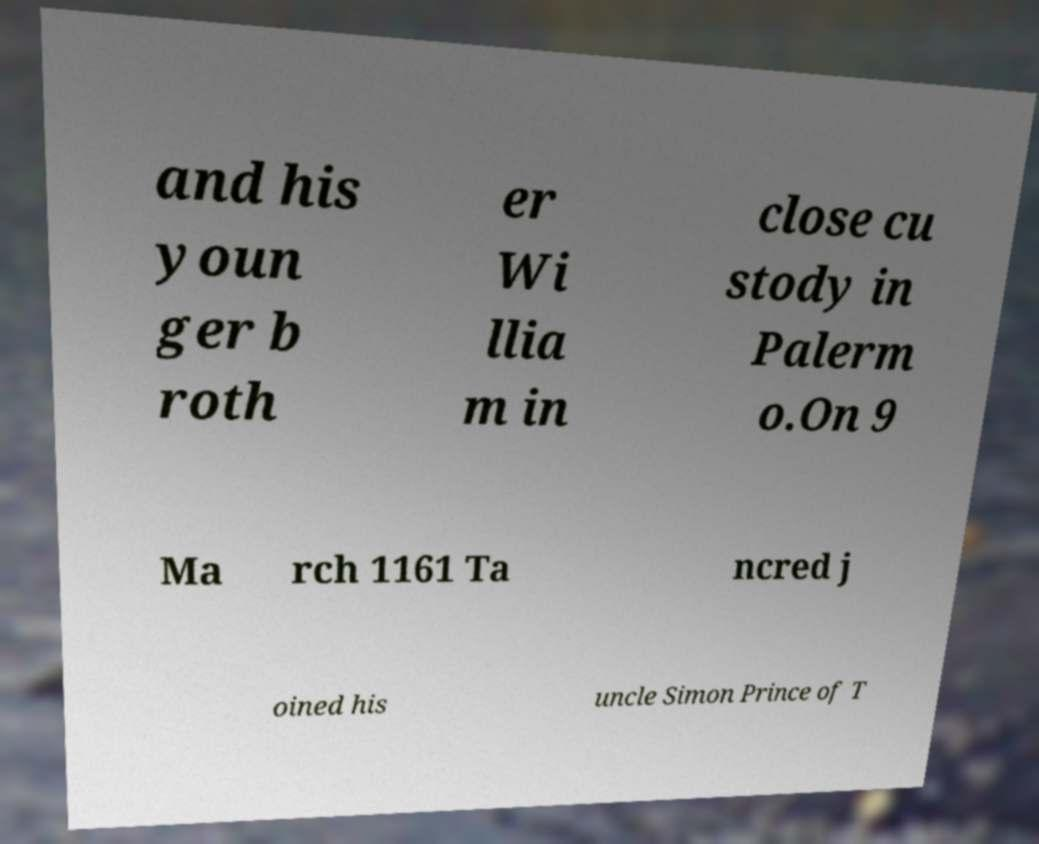What messages or text are displayed in this image? I need them in a readable, typed format. and his youn ger b roth er Wi llia m in close cu stody in Palerm o.On 9 Ma rch 1161 Ta ncred j oined his uncle Simon Prince of T 